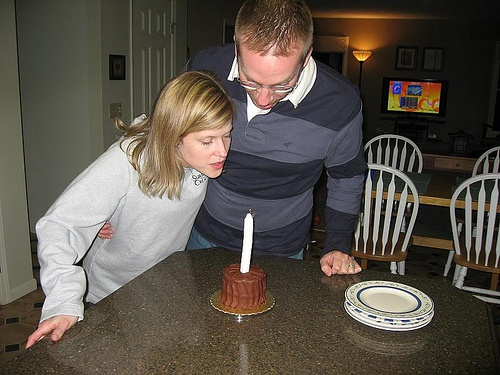Describe the objects in this image and their specific colors. I can see dining table in black and gray tones, people in black, gray, and salmon tones, people in black, lightgray, darkgray, tan, and gray tones, chair in black, darkgray, maroon, and gray tones, and chair in black, darkgray, gray, and maroon tones in this image. 